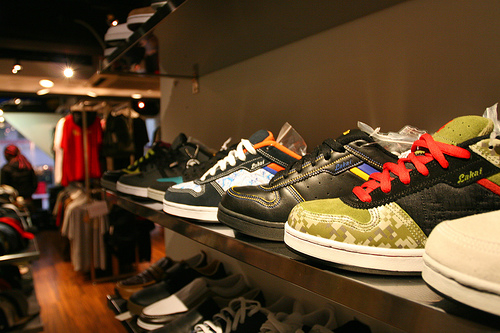<image>
Can you confirm if the shoe is under the mirror? Yes. The shoe is positioned underneath the mirror, with the mirror above it in the vertical space. 